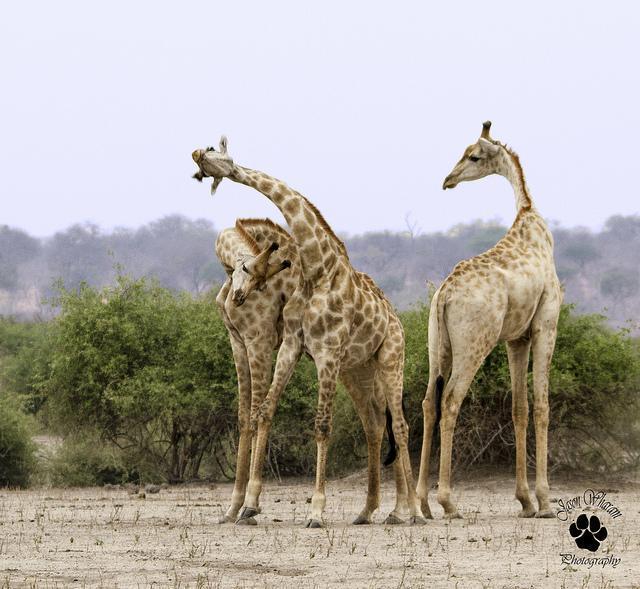How many animals in the picture?
Give a very brief answer. 3. How many giraffes are in the wild?
Give a very brief answer. 3. How many giraffes are there?
Give a very brief answer. 3. How many people are here?
Give a very brief answer. 0. 